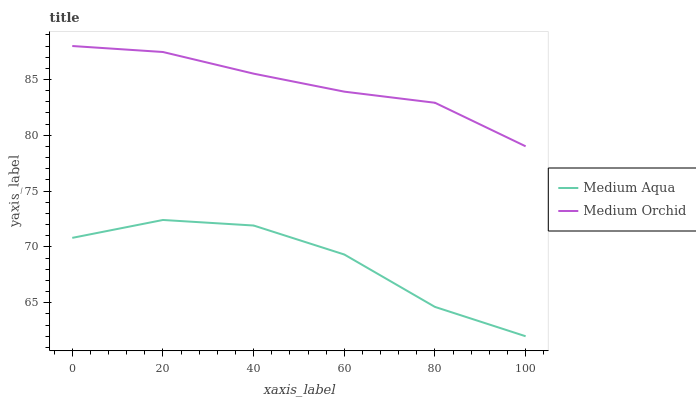Does Medium Aqua have the minimum area under the curve?
Answer yes or no. Yes. Does Medium Orchid have the maximum area under the curve?
Answer yes or no. Yes. Does Medium Aqua have the maximum area under the curve?
Answer yes or no. No. Is Medium Orchid the smoothest?
Answer yes or no. Yes. Is Medium Aqua the roughest?
Answer yes or no. Yes. Is Medium Aqua the smoothest?
Answer yes or no. No. Does Medium Aqua have the lowest value?
Answer yes or no. Yes. Does Medium Orchid have the highest value?
Answer yes or no. Yes. Does Medium Aqua have the highest value?
Answer yes or no. No. Is Medium Aqua less than Medium Orchid?
Answer yes or no. Yes. Is Medium Orchid greater than Medium Aqua?
Answer yes or no. Yes. Does Medium Aqua intersect Medium Orchid?
Answer yes or no. No. 